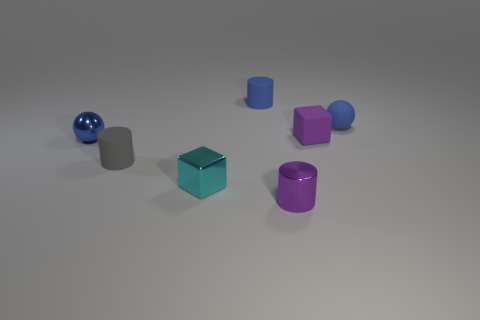What is the shape of the small purple object that is behind the shiny cube?
Your answer should be very brief. Cube. Are there any small purple cylinders that are behind the blue rubber ball behind the small gray matte object?
Provide a succinct answer. No. What color is the small cylinder that is both to the right of the cyan object and behind the small cyan object?
Provide a short and direct response. Blue. There is a small ball that is left of the purple object that is behind the small gray object; is there a small rubber cube that is in front of it?
Ensure brevity in your answer.  No. There is a blue thing that is the same shape as the small purple shiny object; what is its size?
Provide a short and direct response. Small. Is there any other thing that is the same material as the tiny blue cylinder?
Your answer should be compact. Yes. Are any cyan matte cylinders visible?
Your answer should be very brief. No. Is the color of the matte sphere the same as the tiny cylinder that is behind the gray matte thing?
Provide a short and direct response. Yes. What is the size of the cylinder that is right of the blue rubber thing to the left of the sphere behind the small purple matte cube?
Your answer should be compact. Small. What number of small metallic cylinders are the same color as the rubber cube?
Ensure brevity in your answer.  1. 